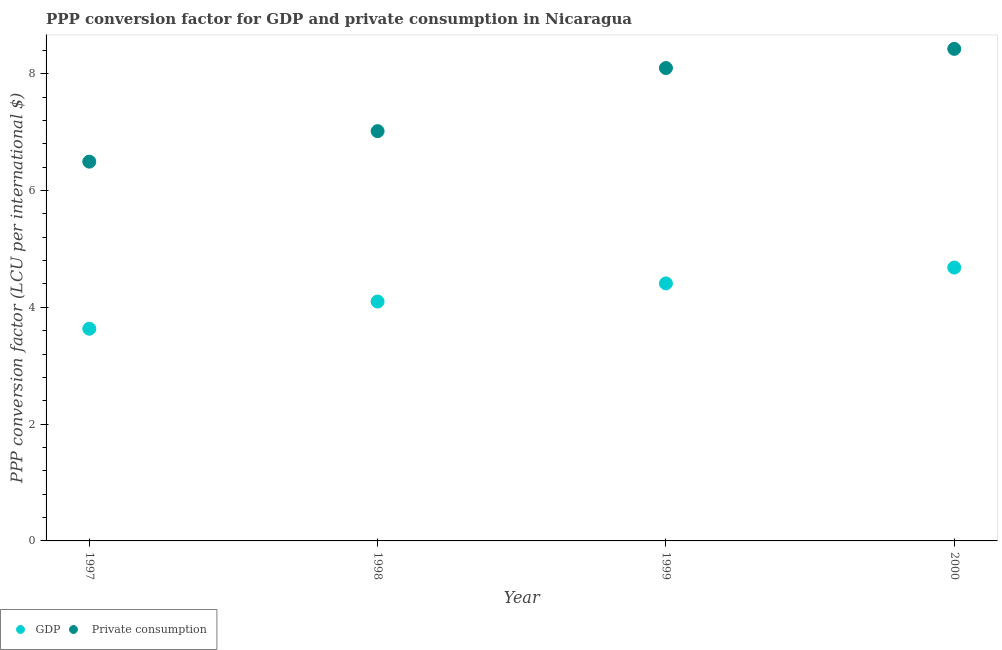How many different coloured dotlines are there?
Keep it short and to the point. 2. What is the ppp conversion factor for private consumption in 1998?
Your answer should be compact. 7.02. Across all years, what is the maximum ppp conversion factor for private consumption?
Keep it short and to the point. 8.43. Across all years, what is the minimum ppp conversion factor for private consumption?
Your answer should be compact. 6.49. What is the total ppp conversion factor for gdp in the graph?
Ensure brevity in your answer.  16.82. What is the difference between the ppp conversion factor for private consumption in 1998 and that in 1999?
Offer a terse response. -1.08. What is the difference between the ppp conversion factor for gdp in 1999 and the ppp conversion factor for private consumption in 2000?
Offer a terse response. -4.02. What is the average ppp conversion factor for gdp per year?
Ensure brevity in your answer.  4.21. In the year 1998, what is the difference between the ppp conversion factor for gdp and ppp conversion factor for private consumption?
Your answer should be very brief. -2.92. In how many years, is the ppp conversion factor for gdp greater than 6.8 LCU?
Your answer should be compact. 0. What is the ratio of the ppp conversion factor for gdp in 1997 to that in 1999?
Your response must be concise. 0.82. What is the difference between the highest and the second highest ppp conversion factor for gdp?
Keep it short and to the point. 0.27. What is the difference between the highest and the lowest ppp conversion factor for gdp?
Offer a terse response. 1.05. In how many years, is the ppp conversion factor for gdp greater than the average ppp conversion factor for gdp taken over all years?
Your answer should be very brief. 2. Is the sum of the ppp conversion factor for private consumption in 1999 and 2000 greater than the maximum ppp conversion factor for gdp across all years?
Offer a very short reply. Yes. Does the ppp conversion factor for gdp monotonically increase over the years?
Give a very brief answer. Yes. Is the ppp conversion factor for private consumption strictly greater than the ppp conversion factor for gdp over the years?
Keep it short and to the point. Yes. How many years are there in the graph?
Your answer should be very brief. 4. What is the difference between two consecutive major ticks on the Y-axis?
Provide a short and direct response. 2. Does the graph contain any zero values?
Your answer should be very brief. No. Does the graph contain grids?
Make the answer very short. No. Where does the legend appear in the graph?
Keep it short and to the point. Bottom left. How many legend labels are there?
Your answer should be very brief. 2. How are the legend labels stacked?
Offer a very short reply. Horizontal. What is the title of the graph?
Offer a terse response. PPP conversion factor for GDP and private consumption in Nicaragua. Does "Investment" appear as one of the legend labels in the graph?
Make the answer very short. No. What is the label or title of the X-axis?
Make the answer very short. Year. What is the label or title of the Y-axis?
Your answer should be compact. PPP conversion factor (LCU per international $). What is the PPP conversion factor (LCU per international $) of GDP in 1997?
Your answer should be compact. 3.63. What is the PPP conversion factor (LCU per international $) of  Private consumption in 1997?
Your answer should be compact. 6.49. What is the PPP conversion factor (LCU per international $) of GDP in 1998?
Your answer should be compact. 4.1. What is the PPP conversion factor (LCU per international $) in  Private consumption in 1998?
Make the answer very short. 7.02. What is the PPP conversion factor (LCU per international $) in GDP in 1999?
Make the answer very short. 4.41. What is the PPP conversion factor (LCU per international $) of  Private consumption in 1999?
Your answer should be compact. 8.1. What is the PPP conversion factor (LCU per international $) of GDP in 2000?
Ensure brevity in your answer.  4.68. What is the PPP conversion factor (LCU per international $) in  Private consumption in 2000?
Keep it short and to the point. 8.43. Across all years, what is the maximum PPP conversion factor (LCU per international $) in GDP?
Your answer should be compact. 4.68. Across all years, what is the maximum PPP conversion factor (LCU per international $) in  Private consumption?
Offer a terse response. 8.43. Across all years, what is the minimum PPP conversion factor (LCU per international $) of GDP?
Your response must be concise. 3.63. Across all years, what is the minimum PPP conversion factor (LCU per international $) in  Private consumption?
Make the answer very short. 6.49. What is the total PPP conversion factor (LCU per international $) in GDP in the graph?
Ensure brevity in your answer.  16.82. What is the total PPP conversion factor (LCU per international $) in  Private consumption in the graph?
Your response must be concise. 30.04. What is the difference between the PPP conversion factor (LCU per international $) of GDP in 1997 and that in 1998?
Make the answer very short. -0.47. What is the difference between the PPP conversion factor (LCU per international $) of  Private consumption in 1997 and that in 1998?
Provide a short and direct response. -0.52. What is the difference between the PPP conversion factor (LCU per international $) in GDP in 1997 and that in 1999?
Your answer should be very brief. -0.78. What is the difference between the PPP conversion factor (LCU per international $) in  Private consumption in 1997 and that in 1999?
Offer a very short reply. -1.6. What is the difference between the PPP conversion factor (LCU per international $) in GDP in 1997 and that in 2000?
Keep it short and to the point. -1.05. What is the difference between the PPP conversion factor (LCU per international $) of  Private consumption in 1997 and that in 2000?
Offer a very short reply. -1.93. What is the difference between the PPP conversion factor (LCU per international $) in GDP in 1998 and that in 1999?
Your answer should be very brief. -0.31. What is the difference between the PPP conversion factor (LCU per international $) in  Private consumption in 1998 and that in 1999?
Provide a succinct answer. -1.08. What is the difference between the PPP conversion factor (LCU per international $) of GDP in 1998 and that in 2000?
Offer a terse response. -0.58. What is the difference between the PPP conversion factor (LCU per international $) in  Private consumption in 1998 and that in 2000?
Make the answer very short. -1.41. What is the difference between the PPP conversion factor (LCU per international $) of GDP in 1999 and that in 2000?
Make the answer very short. -0.27. What is the difference between the PPP conversion factor (LCU per international $) in  Private consumption in 1999 and that in 2000?
Provide a short and direct response. -0.33. What is the difference between the PPP conversion factor (LCU per international $) of GDP in 1997 and the PPP conversion factor (LCU per international $) of  Private consumption in 1998?
Give a very brief answer. -3.38. What is the difference between the PPP conversion factor (LCU per international $) of GDP in 1997 and the PPP conversion factor (LCU per international $) of  Private consumption in 1999?
Provide a succinct answer. -4.46. What is the difference between the PPP conversion factor (LCU per international $) in GDP in 1997 and the PPP conversion factor (LCU per international $) in  Private consumption in 2000?
Your answer should be compact. -4.79. What is the difference between the PPP conversion factor (LCU per international $) in GDP in 1998 and the PPP conversion factor (LCU per international $) in  Private consumption in 1999?
Keep it short and to the point. -4. What is the difference between the PPP conversion factor (LCU per international $) of GDP in 1998 and the PPP conversion factor (LCU per international $) of  Private consumption in 2000?
Make the answer very short. -4.33. What is the difference between the PPP conversion factor (LCU per international $) of GDP in 1999 and the PPP conversion factor (LCU per international $) of  Private consumption in 2000?
Make the answer very short. -4.02. What is the average PPP conversion factor (LCU per international $) in GDP per year?
Your answer should be very brief. 4.21. What is the average PPP conversion factor (LCU per international $) in  Private consumption per year?
Give a very brief answer. 7.51. In the year 1997, what is the difference between the PPP conversion factor (LCU per international $) of GDP and PPP conversion factor (LCU per international $) of  Private consumption?
Provide a short and direct response. -2.86. In the year 1998, what is the difference between the PPP conversion factor (LCU per international $) in GDP and PPP conversion factor (LCU per international $) in  Private consumption?
Make the answer very short. -2.92. In the year 1999, what is the difference between the PPP conversion factor (LCU per international $) of GDP and PPP conversion factor (LCU per international $) of  Private consumption?
Your response must be concise. -3.69. In the year 2000, what is the difference between the PPP conversion factor (LCU per international $) in GDP and PPP conversion factor (LCU per international $) in  Private consumption?
Make the answer very short. -3.75. What is the ratio of the PPP conversion factor (LCU per international $) of GDP in 1997 to that in 1998?
Offer a terse response. 0.89. What is the ratio of the PPP conversion factor (LCU per international $) in  Private consumption in 1997 to that in 1998?
Ensure brevity in your answer.  0.93. What is the ratio of the PPP conversion factor (LCU per international $) of GDP in 1997 to that in 1999?
Offer a very short reply. 0.82. What is the ratio of the PPP conversion factor (LCU per international $) of  Private consumption in 1997 to that in 1999?
Your answer should be compact. 0.8. What is the ratio of the PPP conversion factor (LCU per international $) of GDP in 1997 to that in 2000?
Keep it short and to the point. 0.78. What is the ratio of the PPP conversion factor (LCU per international $) of  Private consumption in 1997 to that in 2000?
Give a very brief answer. 0.77. What is the ratio of the PPP conversion factor (LCU per international $) in GDP in 1998 to that in 1999?
Make the answer very short. 0.93. What is the ratio of the PPP conversion factor (LCU per international $) of  Private consumption in 1998 to that in 1999?
Offer a very short reply. 0.87. What is the ratio of the PPP conversion factor (LCU per international $) in GDP in 1998 to that in 2000?
Give a very brief answer. 0.88. What is the ratio of the PPP conversion factor (LCU per international $) in  Private consumption in 1998 to that in 2000?
Give a very brief answer. 0.83. What is the ratio of the PPP conversion factor (LCU per international $) in GDP in 1999 to that in 2000?
Offer a very short reply. 0.94. What is the ratio of the PPP conversion factor (LCU per international $) of  Private consumption in 1999 to that in 2000?
Keep it short and to the point. 0.96. What is the difference between the highest and the second highest PPP conversion factor (LCU per international $) of GDP?
Offer a very short reply. 0.27. What is the difference between the highest and the second highest PPP conversion factor (LCU per international $) of  Private consumption?
Offer a terse response. 0.33. What is the difference between the highest and the lowest PPP conversion factor (LCU per international $) of GDP?
Your answer should be very brief. 1.05. What is the difference between the highest and the lowest PPP conversion factor (LCU per international $) in  Private consumption?
Offer a very short reply. 1.93. 